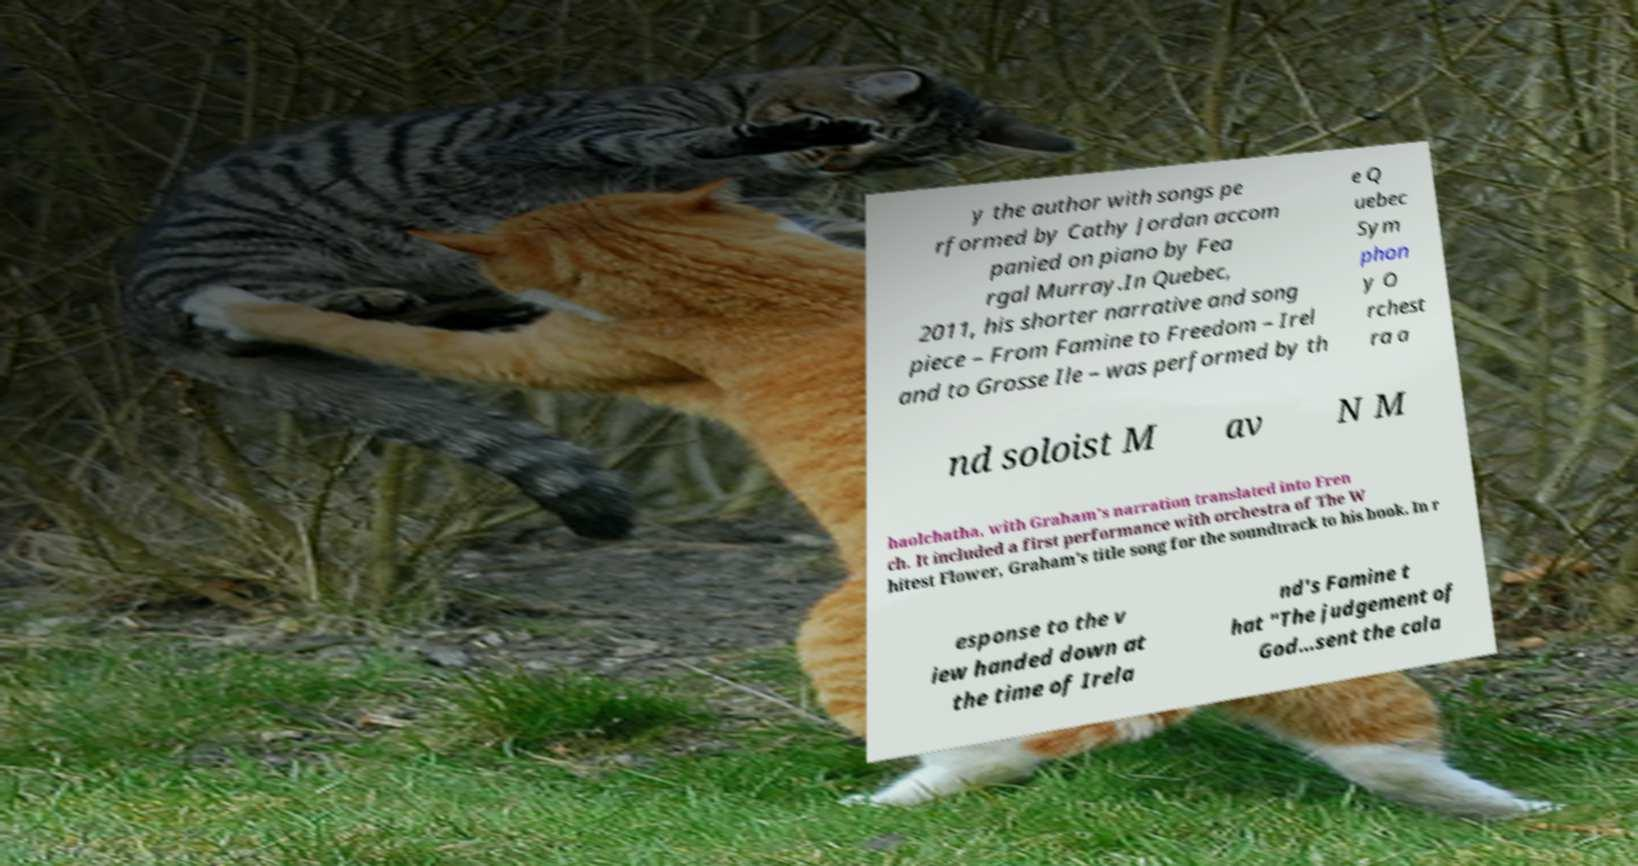For documentation purposes, I need the text within this image transcribed. Could you provide that? y the author with songs pe rformed by Cathy Jordan accom panied on piano by Fea rgal Murray.In Quebec, 2011, his shorter narrative and song piece – From Famine to Freedom – Irel and to Grosse Ile – was performed by th e Q uebec Sym phon y O rchest ra a nd soloist M av N M haolchatha, with Graham's narration translated into Fren ch. It included a first performance with orchestra of The W hitest Flower, Graham's title song for the soundtrack to his book. In r esponse to the v iew handed down at the time of Irela nd's Famine t hat "The judgement of God…sent the cala 